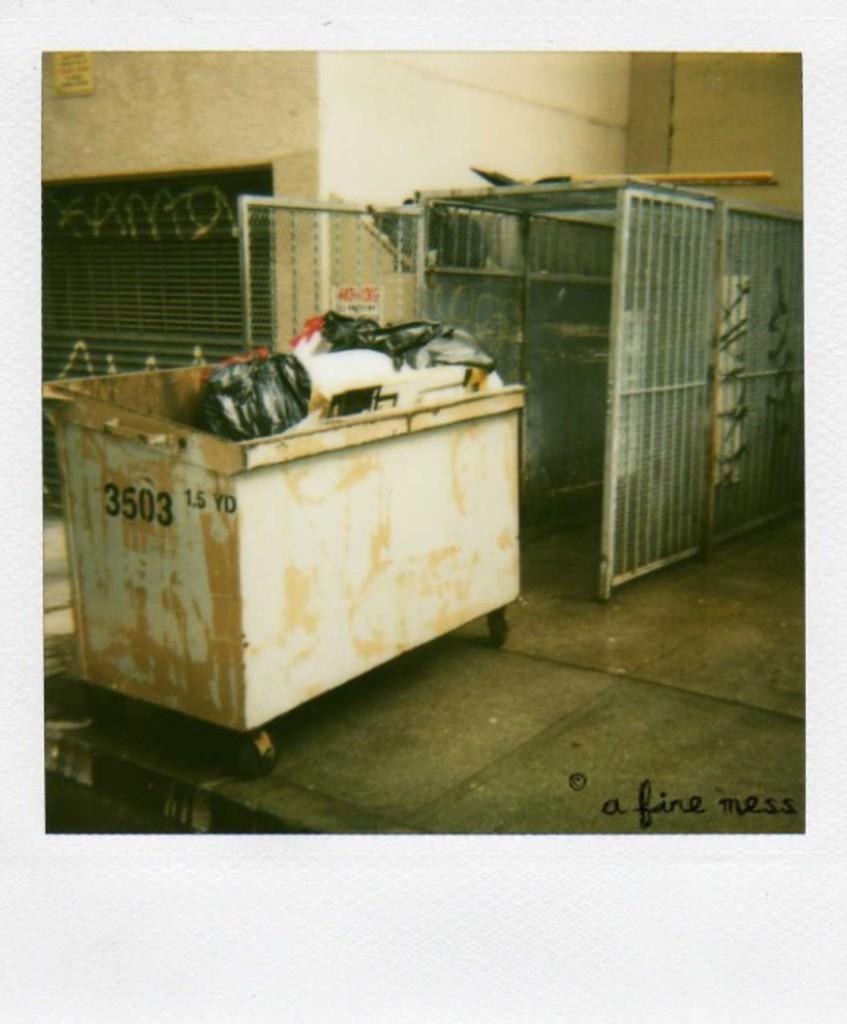Who is this picture credited to?
Keep it short and to the point. A fine mess. What number is on he dumpster?
Your answer should be very brief. 3503. 